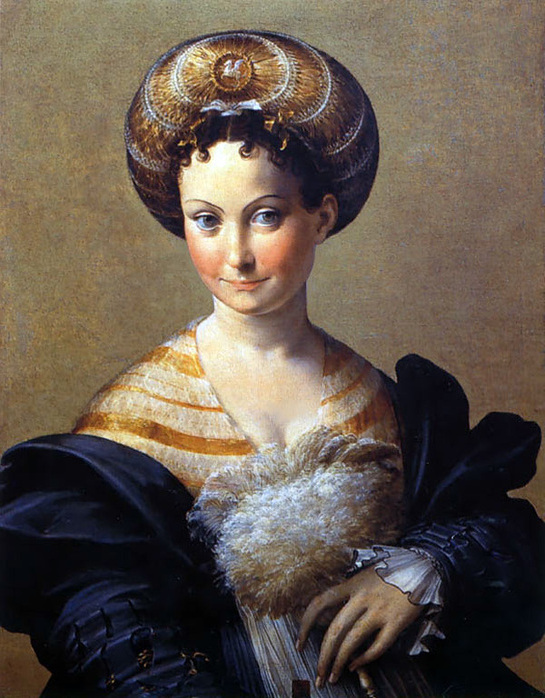What are the key elements in this picture? The image features a woman depicted in a style characteristic of the Italian Renaissance, suggesting her high social status. She wears a luxurious striped gown with a richly textured fur collar and a decorative headdress featuring gold and pearl elements, all indicative of nobility. Her outfit is complemented by a black shawl draped over her shoulders. Her expression is serene, with a slight smile, which alongside her direct gaze, enhances her dignified presence. The background's plain beige tone focuses attention on her, highlighting the detailed portrayal of her attire and accessories. This painting is a fine example of Renaissance art's emphasis on individual identity and detailed realism. 